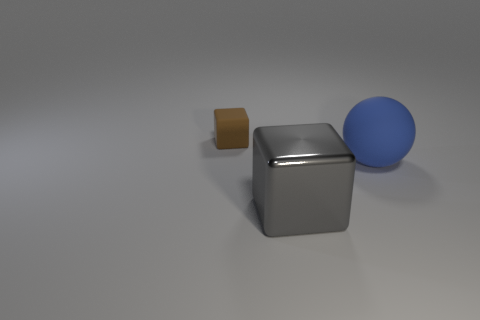Subtract 1 blocks. How many blocks are left? 1 Add 1 big gray balls. How many objects exist? 4 Subtract all gray cubes. How many cubes are left? 1 Subtract all spheres. How many objects are left? 2 Subtract all green spheres. Subtract all brown cylinders. How many spheres are left? 1 Subtract all small blue metal cylinders. Subtract all big gray metal things. How many objects are left? 2 Add 3 big gray objects. How many big gray objects are left? 4 Add 2 big blue matte objects. How many big blue matte objects exist? 3 Subtract 1 gray cubes. How many objects are left? 2 